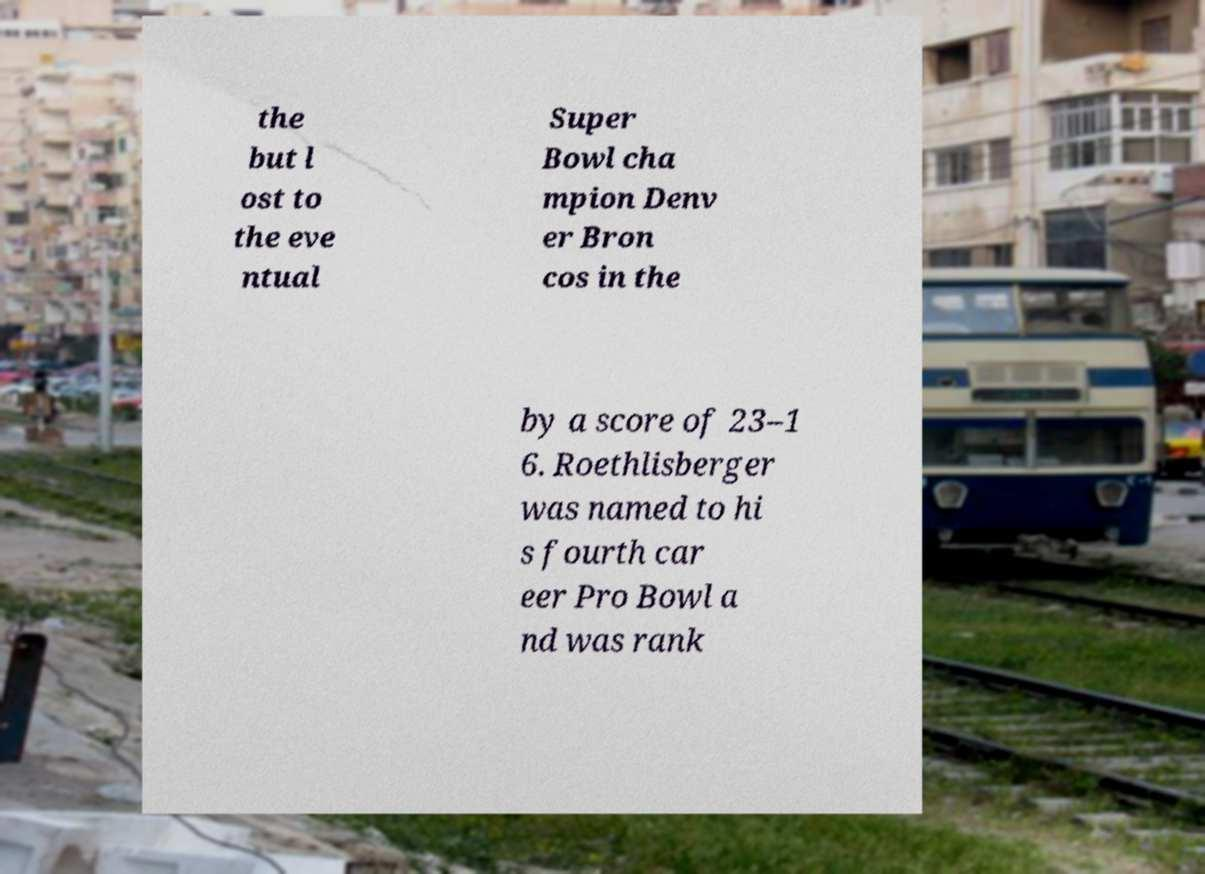Could you extract and type out the text from this image? the but l ost to the eve ntual Super Bowl cha mpion Denv er Bron cos in the by a score of 23–1 6. Roethlisberger was named to hi s fourth car eer Pro Bowl a nd was rank 